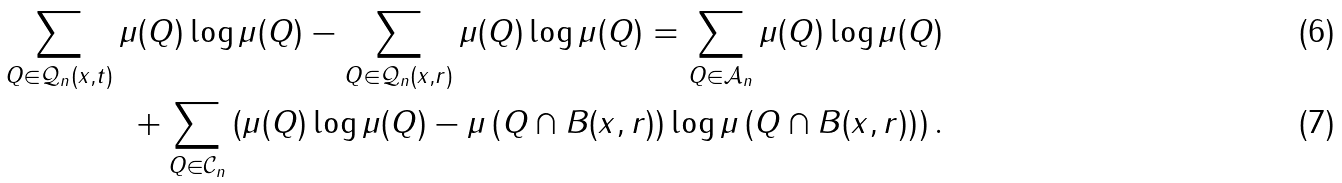Convert formula to latex. <formula><loc_0><loc_0><loc_500><loc_500>\sum _ { Q \in \mathcal { Q } _ { n } ( x , t ) } \mu ( Q ) \log \mu ( Q ) - \sum _ { Q \in \mathcal { Q } _ { n } ( x , r ) } \mu ( Q ) \log \mu ( Q ) = \sum _ { Q \in \mathcal { A } _ { n } } \mu ( Q ) \log \mu ( Q ) \\ + \sum _ { Q \in \mathcal { C } _ { n } } \left ( \mu ( Q ) \log \mu ( Q ) - \mu \left ( Q \cap B ( x , r ) \right ) \log \mu \left ( Q \cap B ( x , r ) \right ) \right ) .</formula> 